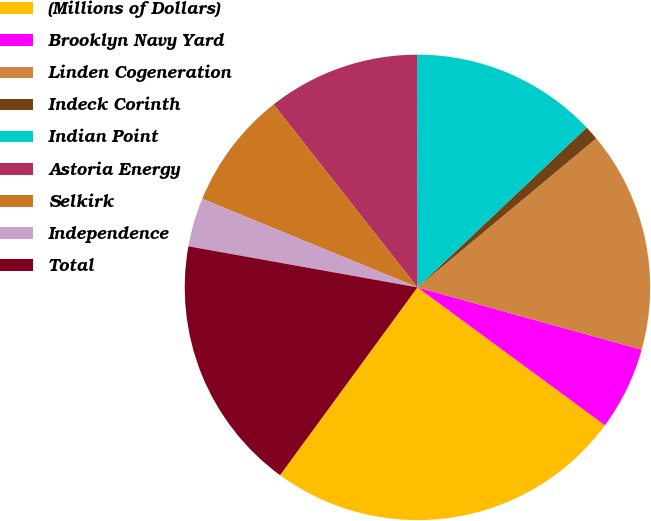<chart> <loc_0><loc_0><loc_500><loc_500><pie_chart><fcel>(Millions of Dollars)<fcel>Brooklyn Navy Yard<fcel>Linden Cogeneration<fcel>Indeck Corinth<fcel>Indian Point<fcel>Astoria Energy<fcel>Selkirk<fcel>Independence<fcel>Total<nl><fcel>24.96%<fcel>5.78%<fcel>15.37%<fcel>0.99%<fcel>12.98%<fcel>10.58%<fcel>8.18%<fcel>3.39%<fcel>17.77%<nl></chart> 